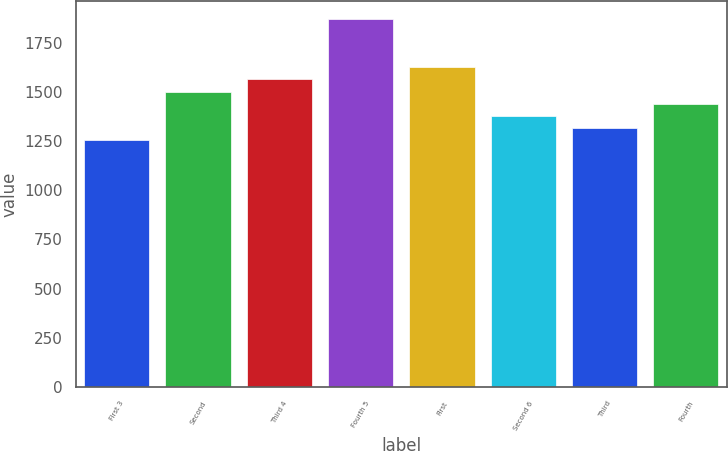<chart> <loc_0><loc_0><loc_500><loc_500><bar_chart><fcel>First 3<fcel>Second<fcel>Third 4<fcel>Fourth 5<fcel>First<fcel>Second 6<fcel>Third<fcel>Fourth<nl><fcel>1256<fcel>1501.6<fcel>1563<fcel>1870<fcel>1624.4<fcel>1378.8<fcel>1317.4<fcel>1440.2<nl></chart> 